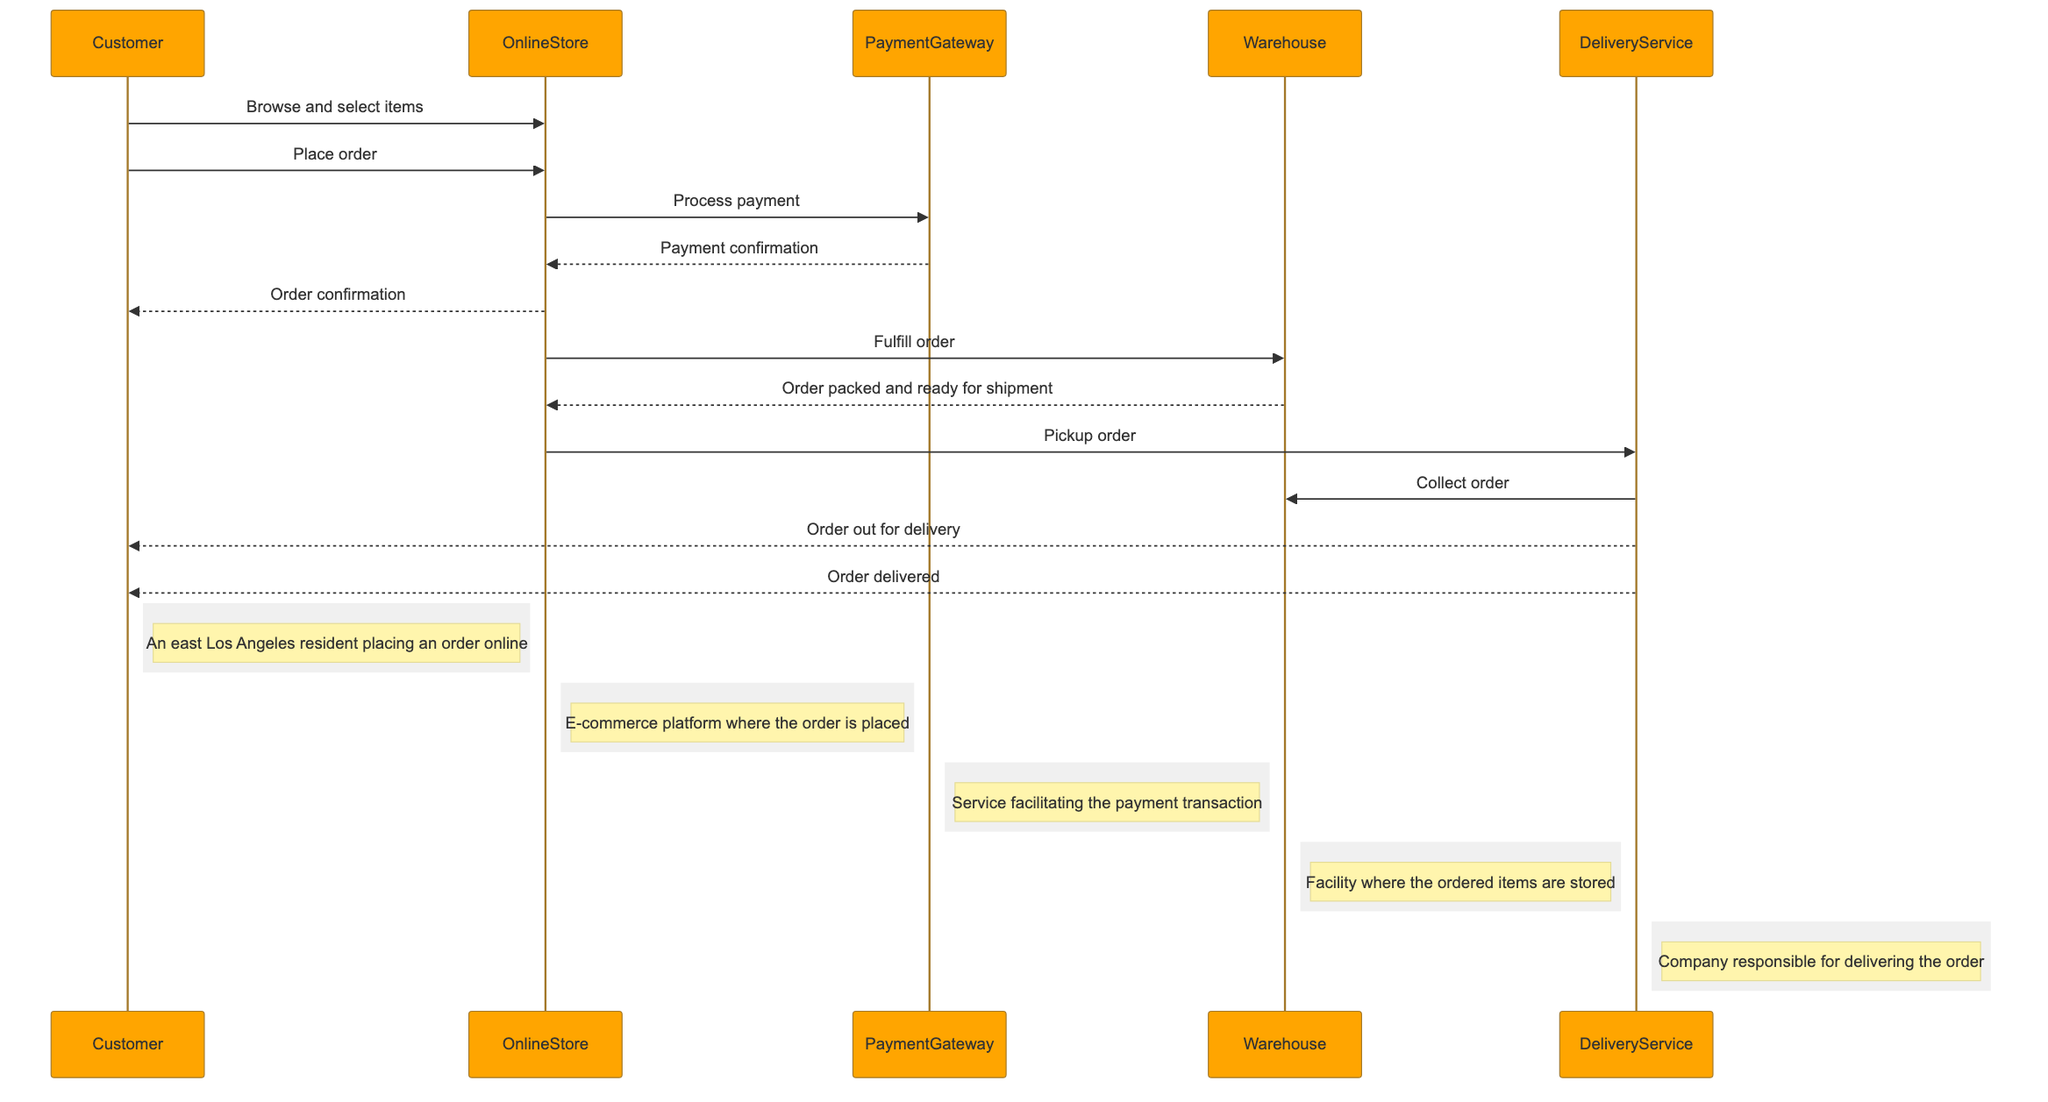What is the first action taken by the Customer? The diagram shows that the first message sent is from the Customer to the OnlineStore, stating "Browse and select items." This indicates that browsing and selecting items is the initial action.
Answer: Browse and select items How many actors are involved in the sequence? By examining the list of actors in the diagram, there are a total of five distinct participants: Customer, OnlineStore, PaymentGateway, Warehouse, and DeliveryService. Counting these gives the total number of actors involved.
Answer: Five What is the last action performed in the delivery sequence? The final message shown in the sequence is "Order delivered," which is sent from the DeliveryService to the Customer. This indicates that delivery completion is the last action performed.
Answer: Order delivered Which actor processes the payment? The diagram indicates that the OnlineStore sends the message "Process payment" to the PaymentGateway, which is responsible for handling the payment transaction. By identifying this, we know the actor that processes the payment.
Answer: PaymentGateway What does the Warehouse do after receiving the fulfill order message? Following the "Fulfill order" message from the OnlineStore to the Warehouse, the Warehouse replies with "Order packed and ready for shipment," indicating it prepares the order for delivery after receiving the fulfillment request.
Answer: Order packed and ready for shipment What action confirms that the payment was successful? The PaymentGateway responds to the OnlineStore with the message "Payment confirmation," which indicates that payment processing has been confirmed as successful. This response denotes that the payment was successfully processed.
Answer: Payment confirmation Which actor is responsible for picking up the order? The diagram shows that after the order is fulfilled, the OnlineStore sends the message "Pickup order" to the DeliveryService, indicating that it is the entity responsible for picking up the order.
Answer: DeliveryService What does the Customer receive after placing the order? After the Customer places the order, the OnlineStore sends "Order confirmation" to the Customer, indicating that they receive an acknowledgment or confirmation of their placed order.
Answer: Order confirmation 